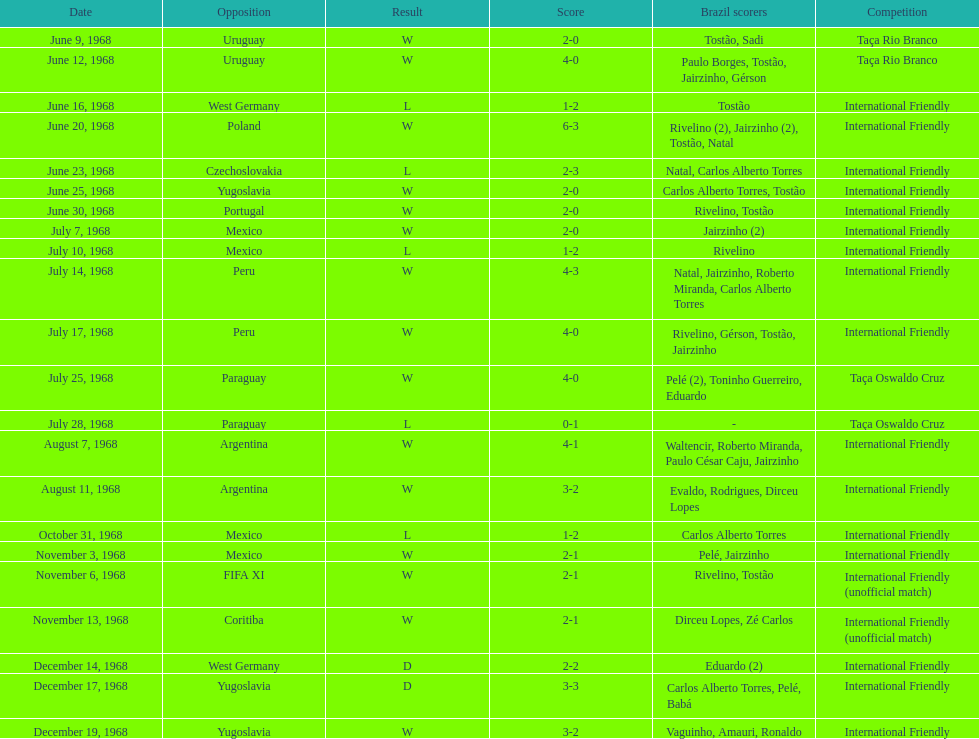What is the count of countries they have participated in? 11. Parse the full table. {'header': ['Date', 'Opposition', 'Result', 'Score', 'Brazil scorers', 'Competition'], 'rows': [['June 9, 1968', 'Uruguay', 'W', '2-0', 'Tostão, Sadi', 'Taça Rio Branco'], ['June 12, 1968', 'Uruguay', 'W', '4-0', 'Paulo Borges, Tostão, Jairzinho, Gérson', 'Taça Rio Branco'], ['June 16, 1968', 'West Germany', 'L', '1-2', 'Tostão', 'International Friendly'], ['June 20, 1968', 'Poland', 'W', '6-3', 'Rivelino (2), Jairzinho (2), Tostão, Natal', 'International Friendly'], ['June 23, 1968', 'Czechoslovakia', 'L', '2-3', 'Natal, Carlos Alberto Torres', 'International Friendly'], ['June 25, 1968', 'Yugoslavia', 'W', '2-0', 'Carlos Alberto Torres, Tostão', 'International Friendly'], ['June 30, 1968', 'Portugal', 'W', '2-0', 'Rivelino, Tostão', 'International Friendly'], ['July 7, 1968', 'Mexico', 'W', '2-0', 'Jairzinho (2)', 'International Friendly'], ['July 10, 1968', 'Mexico', 'L', '1-2', 'Rivelino', 'International Friendly'], ['July 14, 1968', 'Peru', 'W', '4-3', 'Natal, Jairzinho, Roberto Miranda, Carlos Alberto Torres', 'International Friendly'], ['July 17, 1968', 'Peru', 'W', '4-0', 'Rivelino, Gérson, Tostão, Jairzinho', 'International Friendly'], ['July 25, 1968', 'Paraguay', 'W', '4-0', 'Pelé (2), Toninho Guerreiro, Eduardo', 'Taça Oswaldo Cruz'], ['July 28, 1968', 'Paraguay', 'L', '0-1', '-', 'Taça Oswaldo Cruz'], ['August 7, 1968', 'Argentina', 'W', '4-1', 'Waltencir, Roberto Miranda, Paulo César Caju, Jairzinho', 'International Friendly'], ['August 11, 1968', 'Argentina', 'W', '3-2', 'Evaldo, Rodrigues, Dirceu Lopes', 'International Friendly'], ['October 31, 1968', 'Mexico', 'L', '1-2', 'Carlos Alberto Torres', 'International Friendly'], ['November 3, 1968', 'Mexico', 'W', '2-1', 'Pelé, Jairzinho', 'International Friendly'], ['November 6, 1968', 'FIFA XI', 'W', '2-1', 'Rivelino, Tostão', 'International Friendly (unofficial match)'], ['November 13, 1968', 'Coritiba', 'W', '2-1', 'Dirceu Lopes, Zé Carlos', 'International Friendly (unofficial match)'], ['December 14, 1968', 'West Germany', 'D', '2-2', 'Eduardo (2)', 'International Friendly'], ['December 17, 1968', 'Yugoslavia', 'D', '3-3', 'Carlos Alberto Torres, Pelé, Babá', 'International Friendly'], ['December 19, 1968', 'Yugoslavia', 'W', '3-2', 'Vaguinho, Amauri, Ronaldo', 'International Friendly']]} 